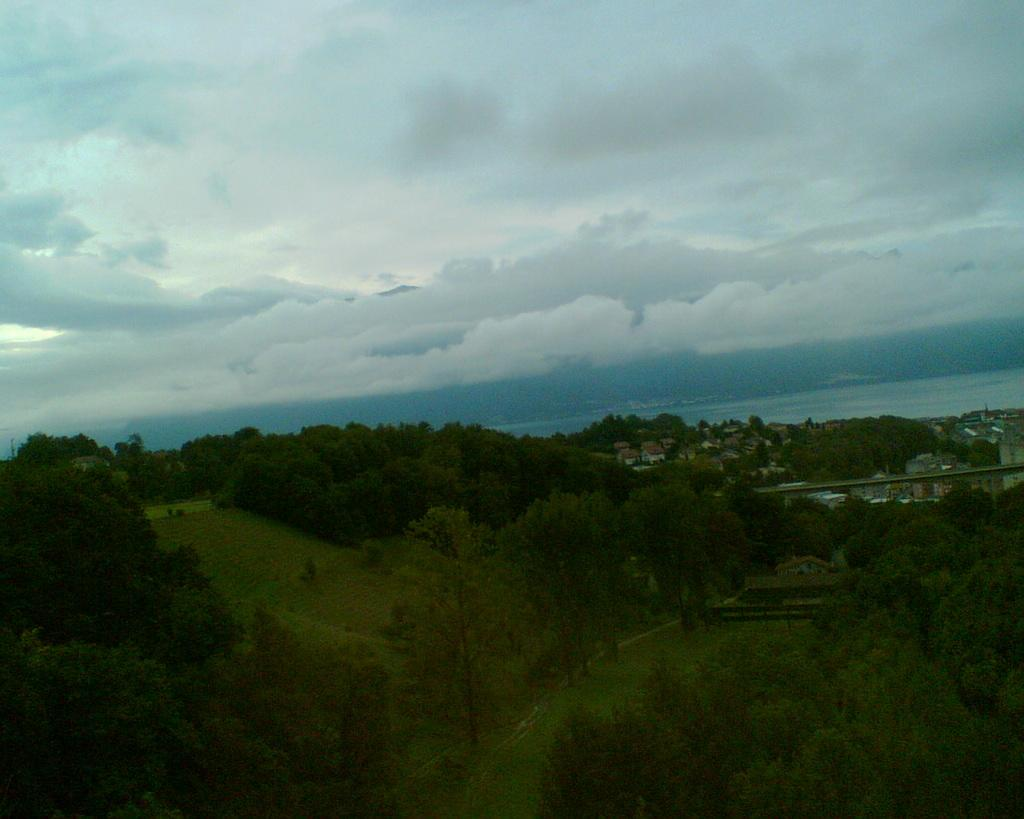What type of vegetation can be seen in the image? There are trees, grass, and plants in the image. What natural elements are visible in the image? The sky and clouds are visible in the image. Can you describe the ground in the image? The ground is covered with grass in the image. How much money is the beggar holding in the image? There is no beggar or money present in the image. What type of berry can be seen growing on the trees in the image? There are no berries visible on the trees in the image. 